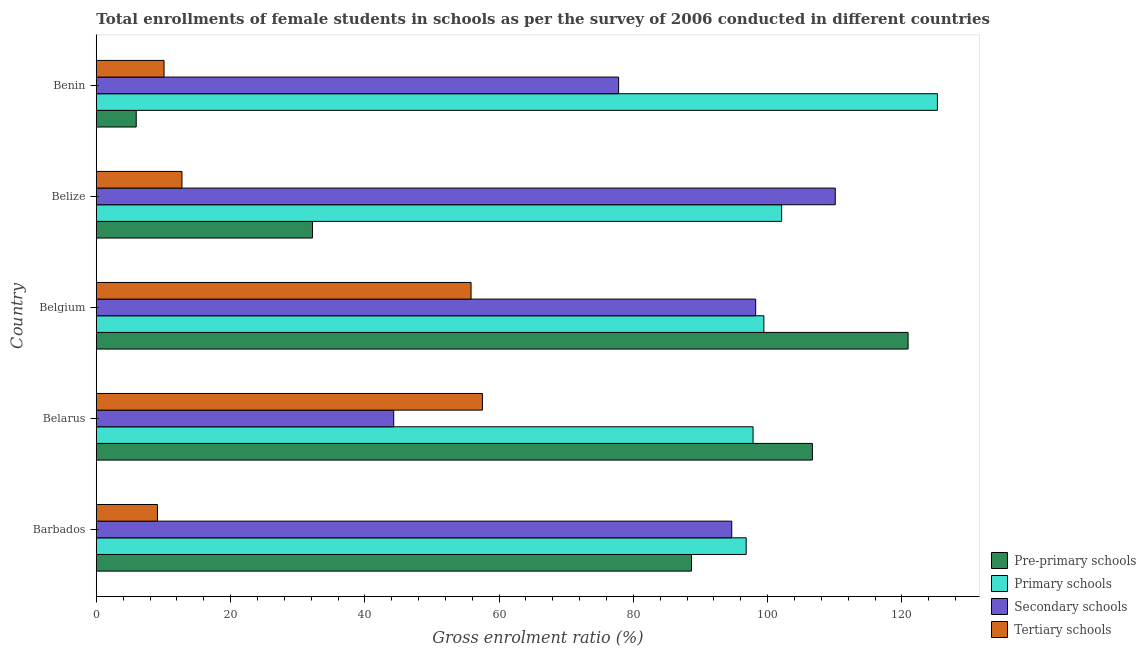How many groups of bars are there?
Provide a succinct answer. 5. Are the number of bars per tick equal to the number of legend labels?
Offer a terse response. Yes. How many bars are there on the 4th tick from the bottom?
Offer a terse response. 4. What is the label of the 4th group of bars from the top?
Offer a very short reply. Belarus. What is the gross enrolment ratio(female) in secondary schools in Belarus?
Your answer should be compact. 44.3. Across all countries, what is the maximum gross enrolment ratio(female) in primary schools?
Your answer should be compact. 125.3. Across all countries, what is the minimum gross enrolment ratio(female) in secondary schools?
Keep it short and to the point. 44.3. In which country was the gross enrolment ratio(female) in tertiary schools maximum?
Offer a terse response. Belarus. In which country was the gross enrolment ratio(female) in tertiary schools minimum?
Your answer should be very brief. Barbados. What is the total gross enrolment ratio(female) in primary schools in the graph?
Keep it short and to the point. 521.47. What is the difference between the gross enrolment ratio(female) in secondary schools in Belgium and that in Benin?
Your response must be concise. 20.42. What is the difference between the gross enrolment ratio(female) in pre-primary schools in Barbados and the gross enrolment ratio(female) in secondary schools in Belgium?
Provide a succinct answer. -9.56. What is the average gross enrolment ratio(female) in primary schools per country?
Make the answer very short. 104.29. What is the difference between the gross enrolment ratio(female) in primary schools and gross enrolment ratio(female) in secondary schools in Belarus?
Provide a succinct answer. 53.53. In how many countries, is the gross enrolment ratio(female) in pre-primary schools greater than 64 %?
Your answer should be very brief. 3. What is the ratio of the gross enrolment ratio(female) in pre-primary schools in Barbados to that in Benin?
Offer a very short reply. 14.92. What is the difference between the highest and the second highest gross enrolment ratio(female) in pre-primary schools?
Offer a terse response. 14.26. What is the difference between the highest and the lowest gross enrolment ratio(female) in pre-primary schools?
Keep it short and to the point. 114.99. What does the 4th bar from the top in Belgium represents?
Ensure brevity in your answer.  Pre-primary schools. What does the 2nd bar from the bottom in Belarus represents?
Offer a terse response. Primary schools. How many bars are there?
Give a very brief answer. 20. Are all the bars in the graph horizontal?
Your answer should be very brief. Yes. How many countries are there in the graph?
Your answer should be very brief. 5. What is the difference between two consecutive major ticks on the X-axis?
Make the answer very short. 20. Are the values on the major ticks of X-axis written in scientific E-notation?
Your response must be concise. No. Does the graph contain any zero values?
Keep it short and to the point. No. Does the graph contain grids?
Your answer should be very brief. No. Where does the legend appear in the graph?
Ensure brevity in your answer.  Bottom right. How many legend labels are there?
Your response must be concise. 4. How are the legend labels stacked?
Your answer should be compact. Vertical. What is the title of the graph?
Keep it short and to the point. Total enrollments of female students in schools as per the survey of 2006 conducted in different countries. What is the Gross enrolment ratio (%) of Pre-primary schools in Barbados?
Provide a short and direct response. 88.66. What is the Gross enrolment ratio (%) of Primary schools in Barbados?
Make the answer very short. 96.81. What is the Gross enrolment ratio (%) of Secondary schools in Barbados?
Keep it short and to the point. 94.66. What is the Gross enrolment ratio (%) in Tertiary schools in Barbados?
Your response must be concise. 9.1. What is the Gross enrolment ratio (%) of Pre-primary schools in Belarus?
Make the answer very short. 106.67. What is the Gross enrolment ratio (%) in Primary schools in Belarus?
Provide a succinct answer. 97.83. What is the Gross enrolment ratio (%) in Secondary schools in Belarus?
Your answer should be very brief. 44.3. What is the Gross enrolment ratio (%) in Tertiary schools in Belarus?
Keep it short and to the point. 57.51. What is the Gross enrolment ratio (%) in Pre-primary schools in Belgium?
Give a very brief answer. 120.93. What is the Gross enrolment ratio (%) of Primary schools in Belgium?
Provide a succinct answer. 99.44. What is the Gross enrolment ratio (%) of Secondary schools in Belgium?
Offer a terse response. 98.22. What is the Gross enrolment ratio (%) of Tertiary schools in Belgium?
Your answer should be compact. 55.82. What is the Gross enrolment ratio (%) of Pre-primary schools in Belize?
Provide a short and direct response. 32.2. What is the Gross enrolment ratio (%) of Primary schools in Belize?
Ensure brevity in your answer.  102.09. What is the Gross enrolment ratio (%) in Secondary schools in Belize?
Make the answer very short. 110.08. What is the Gross enrolment ratio (%) of Tertiary schools in Belize?
Offer a terse response. 12.75. What is the Gross enrolment ratio (%) of Pre-primary schools in Benin?
Your response must be concise. 5.94. What is the Gross enrolment ratio (%) in Primary schools in Benin?
Offer a terse response. 125.3. What is the Gross enrolment ratio (%) in Secondary schools in Benin?
Your answer should be compact. 77.8. What is the Gross enrolment ratio (%) in Tertiary schools in Benin?
Offer a very short reply. 10.09. Across all countries, what is the maximum Gross enrolment ratio (%) of Pre-primary schools?
Your answer should be compact. 120.93. Across all countries, what is the maximum Gross enrolment ratio (%) in Primary schools?
Offer a terse response. 125.3. Across all countries, what is the maximum Gross enrolment ratio (%) of Secondary schools?
Offer a terse response. 110.08. Across all countries, what is the maximum Gross enrolment ratio (%) of Tertiary schools?
Provide a succinct answer. 57.51. Across all countries, what is the minimum Gross enrolment ratio (%) of Pre-primary schools?
Provide a succinct answer. 5.94. Across all countries, what is the minimum Gross enrolment ratio (%) in Primary schools?
Your answer should be compact. 96.81. Across all countries, what is the minimum Gross enrolment ratio (%) of Secondary schools?
Your answer should be very brief. 44.3. Across all countries, what is the minimum Gross enrolment ratio (%) in Tertiary schools?
Your response must be concise. 9.1. What is the total Gross enrolment ratio (%) in Pre-primary schools in the graph?
Ensure brevity in your answer.  354.4. What is the total Gross enrolment ratio (%) in Primary schools in the graph?
Keep it short and to the point. 521.47. What is the total Gross enrolment ratio (%) of Secondary schools in the graph?
Give a very brief answer. 425.06. What is the total Gross enrolment ratio (%) in Tertiary schools in the graph?
Your answer should be compact. 145.28. What is the difference between the Gross enrolment ratio (%) of Pre-primary schools in Barbados and that in Belarus?
Give a very brief answer. -18.01. What is the difference between the Gross enrolment ratio (%) of Primary schools in Barbados and that in Belarus?
Offer a terse response. -1.03. What is the difference between the Gross enrolment ratio (%) in Secondary schools in Barbados and that in Belarus?
Provide a succinct answer. 50.36. What is the difference between the Gross enrolment ratio (%) of Tertiary schools in Barbados and that in Belarus?
Keep it short and to the point. -48.41. What is the difference between the Gross enrolment ratio (%) in Pre-primary schools in Barbados and that in Belgium?
Provide a short and direct response. -32.27. What is the difference between the Gross enrolment ratio (%) of Primary schools in Barbados and that in Belgium?
Give a very brief answer. -2.63. What is the difference between the Gross enrolment ratio (%) of Secondary schools in Barbados and that in Belgium?
Keep it short and to the point. -3.56. What is the difference between the Gross enrolment ratio (%) of Tertiary schools in Barbados and that in Belgium?
Offer a very short reply. -46.72. What is the difference between the Gross enrolment ratio (%) of Pre-primary schools in Barbados and that in Belize?
Ensure brevity in your answer.  56.46. What is the difference between the Gross enrolment ratio (%) of Primary schools in Barbados and that in Belize?
Keep it short and to the point. -5.28. What is the difference between the Gross enrolment ratio (%) in Secondary schools in Barbados and that in Belize?
Give a very brief answer. -15.42. What is the difference between the Gross enrolment ratio (%) of Tertiary schools in Barbados and that in Belize?
Ensure brevity in your answer.  -3.65. What is the difference between the Gross enrolment ratio (%) of Pre-primary schools in Barbados and that in Benin?
Ensure brevity in your answer.  82.72. What is the difference between the Gross enrolment ratio (%) of Primary schools in Barbados and that in Benin?
Provide a short and direct response. -28.49. What is the difference between the Gross enrolment ratio (%) of Secondary schools in Barbados and that in Benin?
Your response must be concise. 16.85. What is the difference between the Gross enrolment ratio (%) of Tertiary schools in Barbados and that in Benin?
Ensure brevity in your answer.  -0.98. What is the difference between the Gross enrolment ratio (%) of Pre-primary schools in Belarus and that in Belgium?
Your answer should be very brief. -14.25. What is the difference between the Gross enrolment ratio (%) of Primary schools in Belarus and that in Belgium?
Make the answer very short. -1.61. What is the difference between the Gross enrolment ratio (%) of Secondary schools in Belarus and that in Belgium?
Your answer should be very brief. -53.92. What is the difference between the Gross enrolment ratio (%) in Tertiary schools in Belarus and that in Belgium?
Make the answer very short. 1.69. What is the difference between the Gross enrolment ratio (%) of Pre-primary schools in Belarus and that in Belize?
Your answer should be very brief. 74.47. What is the difference between the Gross enrolment ratio (%) of Primary schools in Belarus and that in Belize?
Make the answer very short. -4.25. What is the difference between the Gross enrolment ratio (%) in Secondary schools in Belarus and that in Belize?
Provide a succinct answer. -65.78. What is the difference between the Gross enrolment ratio (%) of Tertiary schools in Belarus and that in Belize?
Offer a terse response. 44.76. What is the difference between the Gross enrolment ratio (%) in Pre-primary schools in Belarus and that in Benin?
Give a very brief answer. 100.73. What is the difference between the Gross enrolment ratio (%) in Primary schools in Belarus and that in Benin?
Ensure brevity in your answer.  -27.46. What is the difference between the Gross enrolment ratio (%) of Secondary schools in Belarus and that in Benin?
Your answer should be very brief. -33.51. What is the difference between the Gross enrolment ratio (%) of Tertiary schools in Belarus and that in Benin?
Your response must be concise. 47.43. What is the difference between the Gross enrolment ratio (%) of Pre-primary schools in Belgium and that in Belize?
Your answer should be compact. 88.73. What is the difference between the Gross enrolment ratio (%) of Primary schools in Belgium and that in Belize?
Offer a terse response. -2.64. What is the difference between the Gross enrolment ratio (%) of Secondary schools in Belgium and that in Belize?
Your answer should be compact. -11.85. What is the difference between the Gross enrolment ratio (%) of Tertiary schools in Belgium and that in Belize?
Your answer should be very brief. 43.07. What is the difference between the Gross enrolment ratio (%) of Pre-primary schools in Belgium and that in Benin?
Your answer should be compact. 114.99. What is the difference between the Gross enrolment ratio (%) of Primary schools in Belgium and that in Benin?
Make the answer very short. -25.85. What is the difference between the Gross enrolment ratio (%) of Secondary schools in Belgium and that in Benin?
Give a very brief answer. 20.42. What is the difference between the Gross enrolment ratio (%) of Tertiary schools in Belgium and that in Benin?
Make the answer very short. 45.74. What is the difference between the Gross enrolment ratio (%) of Pre-primary schools in Belize and that in Benin?
Ensure brevity in your answer.  26.26. What is the difference between the Gross enrolment ratio (%) in Primary schools in Belize and that in Benin?
Make the answer very short. -23.21. What is the difference between the Gross enrolment ratio (%) in Secondary schools in Belize and that in Benin?
Ensure brevity in your answer.  32.27. What is the difference between the Gross enrolment ratio (%) of Tertiary schools in Belize and that in Benin?
Your answer should be very brief. 2.67. What is the difference between the Gross enrolment ratio (%) of Pre-primary schools in Barbados and the Gross enrolment ratio (%) of Primary schools in Belarus?
Give a very brief answer. -9.17. What is the difference between the Gross enrolment ratio (%) of Pre-primary schools in Barbados and the Gross enrolment ratio (%) of Secondary schools in Belarus?
Offer a very short reply. 44.36. What is the difference between the Gross enrolment ratio (%) of Pre-primary schools in Barbados and the Gross enrolment ratio (%) of Tertiary schools in Belarus?
Provide a succinct answer. 31.15. What is the difference between the Gross enrolment ratio (%) in Primary schools in Barbados and the Gross enrolment ratio (%) in Secondary schools in Belarus?
Ensure brevity in your answer.  52.51. What is the difference between the Gross enrolment ratio (%) of Primary schools in Barbados and the Gross enrolment ratio (%) of Tertiary schools in Belarus?
Offer a very short reply. 39.3. What is the difference between the Gross enrolment ratio (%) of Secondary schools in Barbados and the Gross enrolment ratio (%) of Tertiary schools in Belarus?
Your answer should be very brief. 37.14. What is the difference between the Gross enrolment ratio (%) of Pre-primary schools in Barbados and the Gross enrolment ratio (%) of Primary schools in Belgium?
Provide a succinct answer. -10.78. What is the difference between the Gross enrolment ratio (%) in Pre-primary schools in Barbados and the Gross enrolment ratio (%) in Secondary schools in Belgium?
Ensure brevity in your answer.  -9.56. What is the difference between the Gross enrolment ratio (%) in Pre-primary schools in Barbados and the Gross enrolment ratio (%) in Tertiary schools in Belgium?
Ensure brevity in your answer.  32.84. What is the difference between the Gross enrolment ratio (%) of Primary schools in Barbados and the Gross enrolment ratio (%) of Secondary schools in Belgium?
Give a very brief answer. -1.41. What is the difference between the Gross enrolment ratio (%) in Primary schools in Barbados and the Gross enrolment ratio (%) in Tertiary schools in Belgium?
Keep it short and to the point. 40.98. What is the difference between the Gross enrolment ratio (%) in Secondary schools in Barbados and the Gross enrolment ratio (%) in Tertiary schools in Belgium?
Offer a very short reply. 38.83. What is the difference between the Gross enrolment ratio (%) of Pre-primary schools in Barbados and the Gross enrolment ratio (%) of Primary schools in Belize?
Offer a very short reply. -13.42. What is the difference between the Gross enrolment ratio (%) of Pre-primary schools in Barbados and the Gross enrolment ratio (%) of Secondary schools in Belize?
Provide a succinct answer. -21.41. What is the difference between the Gross enrolment ratio (%) in Pre-primary schools in Barbados and the Gross enrolment ratio (%) in Tertiary schools in Belize?
Offer a very short reply. 75.91. What is the difference between the Gross enrolment ratio (%) of Primary schools in Barbados and the Gross enrolment ratio (%) of Secondary schools in Belize?
Provide a short and direct response. -13.27. What is the difference between the Gross enrolment ratio (%) in Primary schools in Barbados and the Gross enrolment ratio (%) in Tertiary schools in Belize?
Give a very brief answer. 84.06. What is the difference between the Gross enrolment ratio (%) of Secondary schools in Barbados and the Gross enrolment ratio (%) of Tertiary schools in Belize?
Offer a terse response. 81.91. What is the difference between the Gross enrolment ratio (%) in Pre-primary schools in Barbados and the Gross enrolment ratio (%) in Primary schools in Benin?
Ensure brevity in your answer.  -36.63. What is the difference between the Gross enrolment ratio (%) in Pre-primary schools in Barbados and the Gross enrolment ratio (%) in Secondary schools in Benin?
Give a very brief answer. 10.86. What is the difference between the Gross enrolment ratio (%) of Pre-primary schools in Barbados and the Gross enrolment ratio (%) of Tertiary schools in Benin?
Provide a succinct answer. 78.58. What is the difference between the Gross enrolment ratio (%) of Primary schools in Barbados and the Gross enrolment ratio (%) of Secondary schools in Benin?
Give a very brief answer. 19. What is the difference between the Gross enrolment ratio (%) of Primary schools in Barbados and the Gross enrolment ratio (%) of Tertiary schools in Benin?
Provide a succinct answer. 86.72. What is the difference between the Gross enrolment ratio (%) of Secondary schools in Barbados and the Gross enrolment ratio (%) of Tertiary schools in Benin?
Offer a very short reply. 84.57. What is the difference between the Gross enrolment ratio (%) of Pre-primary schools in Belarus and the Gross enrolment ratio (%) of Primary schools in Belgium?
Your answer should be compact. 7.23. What is the difference between the Gross enrolment ratio (%) of Pre-primary schools in Belarus and the Gross enrolment ratio (%) of Secondary schools in Belgium?
Give a very brief answer. 8.45. What is the difference between the Gross enrolment ratio (%) of Pre-primary schools in Belarus and the Gross enrolment ratio (%) of Tertiary schools in Belgium?
Ensure brevity in your answer.  50.85. What is the difference between the Gross enrolment ratio (%) in Primary schools in Belarus and the Gross enrolment ratio (%) in Secondary schools in Belgium?
Your answer should be very brief. -0.39. What is the difference between the Gross enrolment ratio (%) in Primary schools in Belarus and the Gross enrolment ratio (%) in Tertiary schools in Belgium?
Keep it short and to the point. 42.01. What is the difference between the Gross enrolment ratio (%) of Secondary schools in Belarus and the Gross enrolment ratio (%) of Tertiary schools in Belgium?
Give a very brief answer. -11.52. What is the difference between the Gross enrolment ratio (%) in Pre-primary schools in Belarus and the Gross enrolment ratio (%) in Primary schools in Belize?
Ensure brevity in your answer.  4.59. What is the difference between the Gross enrolment ratio (%) in Pre-primary schools in Belarus and the Gross enrolment ratio (%) in Secondary schools in Belize?
Offer a very short reply. -3.4. What is the difference between the Gross enrolment ratio (%) of Pre-primary schools in Belarus and the Gross enrolment ratio (%) of Tertiary schools in Belize?
Provide a short and direct response. 93.92. What is the difference between the Gross enrolment ratio (%) in Primary schools in Belarus and the Gross enrolment ratio (%) in Secondary schools in Belize?
Your answer should be very brief. -12.24. What is the difference between the Gross enrolment ratio (%) in Primary schools in Belarus and the Gross enrolment ratio (%) in Tertiary schools in Belize?
Offer a very short reply. 85.08. What is the difference between the Gross enrolment ratio (%) in Secondary schools in Belarus and the Gross enrolment ratio (%) in Tertiary schools in Belize?
Keep it short and to the point. 31.55. What is the difference between the Gross enrolment ratio (%) of Pre-primary schools in Belarus and the Gross enrolment ratio (%) of Primary schools in Benin?
Offer a very short reply. -18.62. What is the difference between the Gross enrolment ratio (%) in Pre-primary schools in Belarus and the Gross enrolment ratio (%) in Secondary schools in Benin?
Offer a terse response. 28.87. What is the difference between the Gross enrolment ratio (%) in Pre-primary schools in Belarus and the Gross enrolment ratio (%) in Tertiary schools in Benin?
Offer a very short reply. 96.59. What is the difference between the Gross enrolment ratio (%) in Primary schools in Belarus and the Gross enrolment ratio (%) in Secondary schools in Benin?
Provide a short and direct response. 20.03. What is the difference between the Gross enrolment ratio (%) of Primary schools in Belarus and the Gross enrolment ratio (%) of Tertiary schools in Benin?
Your answer should be compact. 87.75. What is the difference between the Gross enrolment ratio (%) of Secondary schools in Belarus and the Gross enrolment ratio (%) of Tertiary schools in Benin?
Give a very brief answer. 34.21. What is the difference between the Gross enrolment ratio (%) of Pre-primary schools in Belgium and the Gross enrolment ratio (%) of Primary schools in Belize?
Provide a succinct answer. 18.84. What is the difference between the Gross enrolment ratio (%) in Pre-primary schools in Belgium and the Gross enrolment ratio (%) in Secondary schools in Belize?
Your answer should be compact. 10.85. What is the difference between the Gross enrolment ratio (%) in Pre-primary schools in Belgium and the Gross enrolment ratio (%) in Tertiary schools in Belize?
Ensure brevity in your answer.  108.18. What is the difference between the Gross enrolment ratio (%) of Primary schools in Belgium and the Gross enrolment ratio (%) of Secondary schools in Belize?
Your answer should be very brief. -10.63. What is the difference between the Gross enrolment ratio (%) in Primary schools in Belgium and the Gross enrolment ratio (%) in Tertiary schools in Belize?
Your answer should be very brief. 86.69. What is the difference between the Gross enrolment ratio (%) in Secondary schools in Belgium and the Gross enrolment ratio (%) in Tertiary schools in Belize?
Offer a very short reply. 85.47. What is the difference between the Gross enrolment ratio (%) of Pre-primary schools in Belgium and the Gross enrolment ratio (%) of Primary schools in Benin?
Offer a terse response. -4.37. What is the difference between the Gross enrolment ratio (%) in Pre-primary schools in Belgium and the Gross enrolment ratio (%) in Secondary schools in Benin?
Your response must be concise. 43.12. What is the difference between the Gross enrolment ratio (%) in Pre-primary schools in Belgium and the Gross enrolment ratio (%) in Tertiary schools in Benin?
Offer a terse response. 110.84. What is the difference between the Gross enrolment ratio (%) of Primary schools in Belgium and the Gross enrolment ratio (%) of Secondary schools in Benin?
Your response must be concise. 21.64. What is the difference between the Gross enrolment ratio (%) in Primary schools in Belgium and the Gross enrolment ratio (%) in Tertiary schools in Benin?
Give a very brief answer. 89.36. What is the difference between the Gross enrolment ratio (%) in Secondary schools in Belgium and the Gross enrolment ratio (%) in Tertiary schools in Benin?
Offer a very short reply. 88.14. What is the difference between the Gross enrolment ratio (%) of Pre-primary schools in Belize and the Gross enrolment ratio (%) of Primary schools in Benin?
Your answer should be compact. -93.1. What is the difference between the Gross enrolment ratio (%) in Pre-primary schools in Belize and the Gross enrolment ratio (%) in Secondary schools in Benin?
Offer a terse response. -45.61. What is the difference between the Gross enrolment ratio (%) in Pre-primary schools in Belize and the Gross enrolment ratio (%) in Tertiary schools in Benin?
Offer a very short reply. 22.11. What is the difference between the Gross enrolment ratio (%) of Primary schools in Belize and the Gross enrolment ratio (%) of Secondary schools in Benin?
Provide a short and direct response. 24.28. What is the difference between the Gross enrolment ratio (%) in Primary schools in Belize and the Gross enrolment ratio (%) in Tertiary schools in Benin?
Keep it short and to the point. 92. What is the difference between the Gross enrolment ratio (%) of Secondary schools in Belize and the Gross enrolment ratio (%) of Tertiary schools in Benin?
Make the answer very short. 99.99. What is the average Gross enrolment ratio (%) of Pre-primary schools per country?
Offer a very short reply. 70.88. What is the average Gross enrolment ratio (%) in Primary schools per country?
Give a very brief answer. 104.29. What is the average Gross enrolment ratio (%) of Secondary schools per country?
Your answer should be compact. 85.01. What is the average Gross enrolment ratio (%) in Tertiary schools per country?
Provide a succinct answer. 29.06. What is the difference between the Gross enrolment ratio (%) of Pre-primary schools and Gross enrolment ratio (%) of Primary schools in Barbados?
Give a very brief answer. -8.15. What is the difference between the Gross enrolment ratio (%) of Pre-primary schools and Gross enrolment ratio (%) of Secondary schools in Barbados?
Your answer should be very brief. -6. What is the difference between the Gross enrolment ratio (%) in Pre-primary schools and Gross enrolment ratio (%) in Tertiary schools in Barbados?
Provide a short and direct response. 79.56. What is the difference between the Gross enrolment ratio (%) in Primary schools and Gross enrolment ratio (%) in Secondary schools in Barbados?
Your answer should be very brief. 2.15. What is the difference between the Gross enrolment ratio (%) in Primary schools and Gross enrolment ratio (%) in Tertiary schools in Barbados?
Give a very brief answer. 87.7. What is the difference between the Gross enrolment ratio (%) of Secondary schools and Gross enrolment ratio (%) of Tertiary schools in Barbados?
Offer a very short reply. 85.55. What is the difference between the Gross enrolment ratio (%) in Pre-primary schools and Gross enrolment ratio (%) in Primary schools in Belarus?
Offer a terse response. 8.84. What is the difference between the Gross enrolment ratio (%) in Pre-primary schools and Gross enrolment ratio (%) in Secondary schools in Belarus?
Ensure brevity in your answer.  62.37. What is the difference between the Gross enrolment ratio (%) in Pre-primary schools and Gross enrolment ratio (%) in Tertiary schools in Belarus?
Provide a succinct answer. 49.16. What is the difference between the Gross enrolment ratio (%) of Primary schools and Gross enrolment ratio (%) of Secondary schools in Belarus?
Keep it short and to the point. 53.54. What is the difference between the Gross enrolment ratio (%) of Primary schools and Gross enrolment ratio (%) of Tertiary schools in Belarus?
Keep it short and to the point. 40.32. What is the difference between the Gross enrolment ratio (%) in Secondary schools and Gross enrolment ratio (%) in Tertiary schools in Belarus?
Your answer should be very brief. -13.21. What is the difference between the Gross enrolment ratio (%) in Pre-primary schools and Gross enrolment ratio (%) in Primary schools in Belgium?
Make the answer very short. 21.48. What is the difference between the Gross enrolment ratio (%) in Pre-primary schools and Gross enrolment ratio (%) in Secondary schools in Belgium?
Your answer should be compact. 22.71. What is the difference between the Gross enrolment ratio (%) of Pre-primary schools and Gross enrolment ratio (%) of Tertiary schools in Belgium?
Give a very brief answer. 65.1. What is the difference between the Gross enrolment ratio (%) of Primary schools and Gross enrolment ratio (%) of Secondary schools in Belgium?
Provide a short and direct response. 1.22. What is the difference between the Gross enrolment ratio (%) in Primary schools and Gross enrolment ratio (%) in Tertiary schools in Belgium?
Keep it short and to the point. 43.62. What is the difference between the Gross enrolment ratio (%) of Secondary schools and Gross enrolment ratio (%) of Tertiary schools in Belgium?
Your answer should be compact. 42.4. What is the difference between the Gross enrolment ratio (%) in Pre-primary schools and Gross enrolment ratio (%) in Primary schools in Belize?
Give a very brief answer. -69.89. What is the difference between the Gross enrolment ratio (%) of Pre-primary schools and Gross enrolment ratio (%) of Secondary schools in Belize?
Your answer should be very brief. -77.88. What is the difference between the Gross enrolment ratio (%) in Pre-primary schools and Gross enrolment ratio (%) in Tertiary schools in Belize?
Your response must be concise. 19.45. What is the difference between the Gross enrolment ratio (%) of Primary schools and Gross enrolment ratio (%) of Secondary schools in Belize?
Make the answer very short. -7.99. What is the difference between the Gross enrolment ratio (%) in Primary schools and Gross enrolment ratio (%) in Tertiary schools in Belize?
Keep it short and to the point. 89.33. What is the difference between the Gross enrolment ratio (%) in Secondary schools and Gross enrolment ratio (%) in Tertiary schools in Belize?
Keep it short and to the point. 97.32. What is the difference between the Gross enrolment ratio (%) in Pre-primary schools and Gross enrolment ratio (%) in Primary schools in Benin?
Provide a short and direct response. -119.35. What is the difference between the Gross enrolment ratio (%) of Pre-primary schools and Gross enrolment ratio (%) of Secondary schools in Benin?
Your response must be concise. -71.86. What is the difference between the Gross enrolment ratio (%) in Pre-primary schools and Gross enrolment ratio (%) in Tertiary schools in Benin?
Ensure brevity in your answer.  -4.14. What is the difference between the Gross enrolment ratio (%) in Primary schools and Gross enrolment ratio (%) in Secondary schools in Benin?
Keep it short and to the point. 47.49. What is the difference between the Gross enrolment ratio (%) in Primary schools and Gross enrolment ratio (%) in Tertiary schools in Benin?
Give a very brief answer. 115.21. What is the difference between the Gross enrolment ratio (%) in Secondary schools and Gross enrolment ratio (%) in Tertiary schools in Benin?
Make the answer very short. 67.72. What is the ratio of the Gross enrolment ratio (%) in Pre-primary schools in Barbados to that in Belarus?
Keep it short and to the point. 0.83. What is the ratio of the Gross enrolment ratio (%) of Secondary schools in Barbados to that in Belarus?
Provide a short and direct response. 2.14. What is the ratio of the Gross enrolment ratio (%) in Tertiary schools in Barbados to that in Belarus?
Your answer should be compact. 0.16. What is the ratio of the Gross enrolment ratio (%) of Pre-primary schools in Barbados to that in Belgium?
Offer a terse response. 0.73. What is the ratio of the Gross enrolment ratio (%) in Primary schools in Barbados to that in Belgium?
Provide a succinct answer. 0.97. What is the ratio of the Gross enrolment ratio (%) of Secondary schools in Barbados to that in Belgium?
Ensure brevity in your answer.  0.96. What is the ratio of the Gross enrolment ratio (%) of Tertiary schools in Barbados to that in Belgium?
Offer a very short reply. 0.16. What is the ratio of the Gross enrolment ratio (%) in Pre-primary schools in Barbados to that in Belize?
Give a very brief answer. 2.75. What is the ratio of the Gross enrolment ratio (%) in Primary schools in Barbados to that in Belize?
Your answer should be compact. 0.95. What is the ratio of the Gross enrolment ratio (%) in Secondary schools in Barbados to that in Belize?
Keep it short and to the point. 0.86. What is the ratio of the Gross enrolment ratio (%) of Tertiary schools in Barbados to that in Belize?
Provide a succinct answer. 0.71. What is the ratio of the Gross enrolment ratio (%) in Pre-primary schools in Barbados to that in Benin?
Provide a short and direct response. 14.92. What is the ratio of the Gross enrolment ratio (%) in Primary schools in Barbados to that in Benin?
Your response must be concise. 0.77. What is the ratio of the Gross enrolment ratio (%) of Secondary schools in Barbados to that in Benin?
Make the answer very short. 1.22. What is the ratio of the Gross enrolment ratio (%) of Tertiary schools in Barbados to that in Benin?
Provide a short and direct response. 0.9. What is the ratio of the Gross enrolment ratio (%) of Pre-primary schools in Belarus to that in Belgium?
Keep it short and to the point. 0.88. What is the ratio of the Gross enrolment ratio (%) in Primary schools in Belarus to that in Belgium?
Your answer should be compact. 0.98. What is the ratio of the Gross enrolment ratio (%) of Secondary schools in Belarus to that in Belgium?
Make the answer very short. 0.45. What is the ratio of the Gross enrolment ratio (%) in Tertiary schools in Belarus to that in Belgium?
Make the answer very short. 1.03. What is the ratio of the Gross enrolment ratio (%) in Pre-primary schools in Belarus to that in Belize?
Ensure brevity in your answer.  3.31. What is the ratio of the Gross enrolment ratio (%) in Primary schools in Belarus to that in Belize?
Your answer should be compact. 0.96. What is the ratio of the Gross enrolment ratio (%) of Secondary schools in Belarus to that in Belize?
Keep it short and to the point. 0.4. What is the ratio of the Gross enrolment ratio (%) in Tertiary schools in Belarus to that in Belize?
Offer a terse response. 4.51. What is the ratio of the Gross enrolment ratio (%) in Pre-primary schools in Belarus to that in Benin?
Your answer should be very brief. 17.95. What is the ratio of the Gross enrolment ratio (%) in Primary schools in Belarus to that in Benin?
Your answer should be compact. 0.78. What is the ratio of the Gross enrolment ratio (%) in Secondary schools in Belarus to that in Benin?
Ensure brevity in your answer.  0.57. What is the ratio of the Gross enrolment ratio (%) in Tertiary schools in Belarus to that in Benin?
Your response must be concise. 5.7. What is the ratio of the Gross enrolment ratio (%) of Pre-primary schools in Belgium to that in Belize?
Keep it short and to the point. 3.76. What is the ratio of the Gross enrolment ratio (%) of Primary schools in Belgium to that in Belize?
Give a very brief answer. 0.97. What is the ratio of the Gross enrolment ratio (%) of Secondary schools in Belgium to that in Belize?
Your answer should be very brief. 0.89. What is the ratio of the Gross enrolment ratio (%) of Tertiary schools in Belgium to that in Belize?
Ensure brevity in your answer.  4.38. What is the ratio of the Gross enrolment ratio (%) of Pre-primary schools in Belgium to that in Benin?
Give a very brief answer. 20.35. What is the ratio of the Gross enrolment ratio (%) of Primary schools in Belgium to that in Benin?
Provide a short and direct response. 0.79. What is the ratio of the Gross enrolment ratio (%) in Secondary schools in Belgium to that in Benin?
Make the answer very short. 1.26. What is the ratio of the Gross enrolment ratio (%) in Tertiary schools in Belgium to that in Benin?
Make the answer very short. 5.54. What is the ratio of the Gross enrolment ratio (%) in Pre-primary schools in Belize to that in Benin?
Provide a short and direct response. 5.42. What is the ratio of the Gross enrolment ratio (%) in Primary schools in Belize to that in Benin?
Give a very brief answer. 0.81. What is the ratio of the Gross enrolment ratio (%) of Secondary schools in Belize to that in Benin?
Provide a succinct answer. 1.41. What is the ratio of the Gross enrolment ratio (%) in Tertiary schools in Belize to that in Benin?
Your answer should be very brief. 1.26. What is the difference between the highest and the second highest Gross enrolment ratio (%) in Pre-primary schools?
Give a very brief answer. 14.25. What is the difference between the highest and the second highest Gross enrolment ratio (%) of Primary schools?
Your response must be concise. 23.21. What is the difference between the highest and the second highest Gross enrolment ratio (%) of Secondary schools?
Make the answer very short. 11.85. What is the difference between the highest and the second highest Gross enrolment ratio (%) in Tertiary schools?
Your response must be concise. 1.69. What is the difference between the highest and the lowest Gross enrolment ratio (%) in Pre-primary schools?
Give a very brief answer. 114.99. What is the difference between the highest and the lowest Gross enrolment ratio (%) of Primary schools?
Your answer should be compact. 28.49. What is the difference between the highest and the lowest Gross enrolment ratio (%) of Secondary schools?
Offer a very short reply. 65.78. What is the difference between the highest and the lowest Gross enrolment ratio (%) of Tertiary schools?
Your response must be concise. 48.41. 